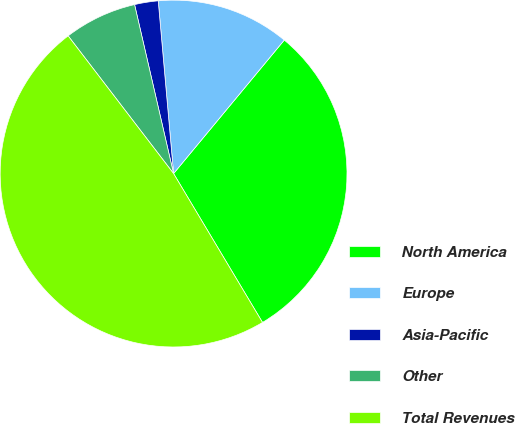Convert chart. <chart><loc_0><loc_0><loc_500><loc_500><pie_chart><fcel>North America<fcel>Europe<fcel>Asia-Pacific<fcel>Other<fcel>Total Revenues<nl><fcel>30.41%<fcel>12.43%<fcel>2.2%<fcel>6.79%<fcel>48.17%<nl></chart> 